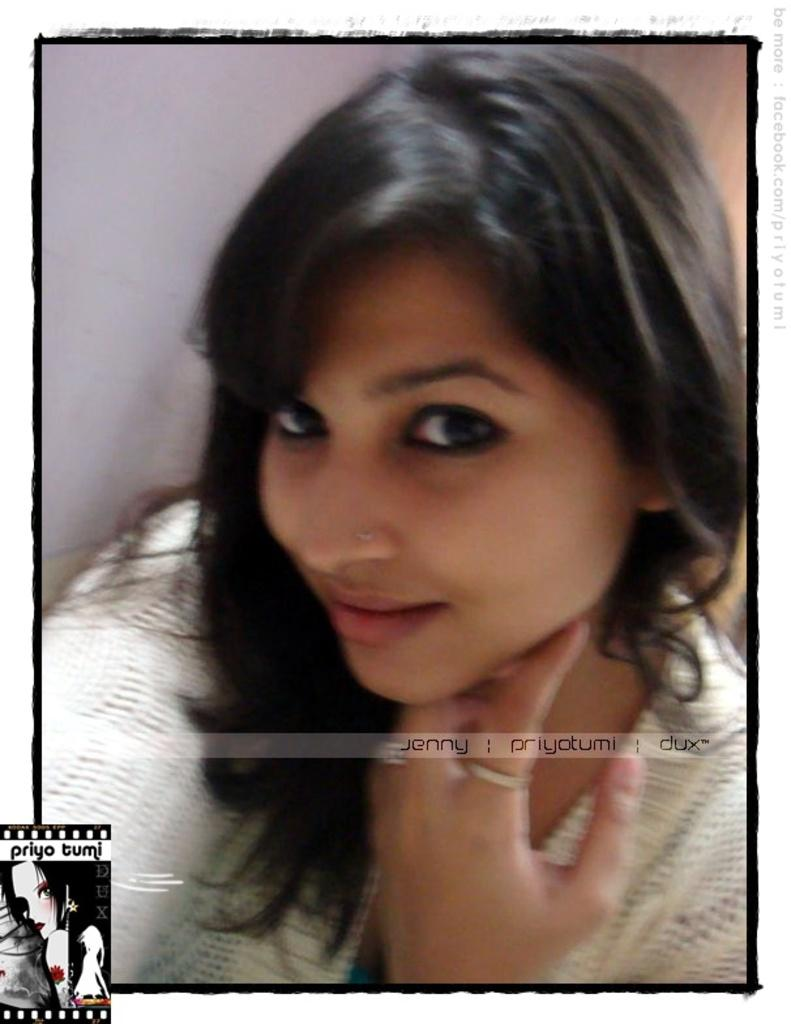Who is present in the image? There is a woman in the image. What is the woman doing in the image? The woman is smiling in the image. What is the woman wearing in the image? The woman is wearing a white dress in the image. Are there any imperfections or marks on the image? Yes, there are watermarks on the image. Can you describe the background of the image? It is less certain due to the ambiguity in the transcription, but there may be a wall in the image. What type of vein is visible on the woman's side in the image? There is no visible vein on the woman's side in the image. What type of range can be seen in the background of the image? There is no range visible in the background of the image, as the background is uncertain due to the transcription. 